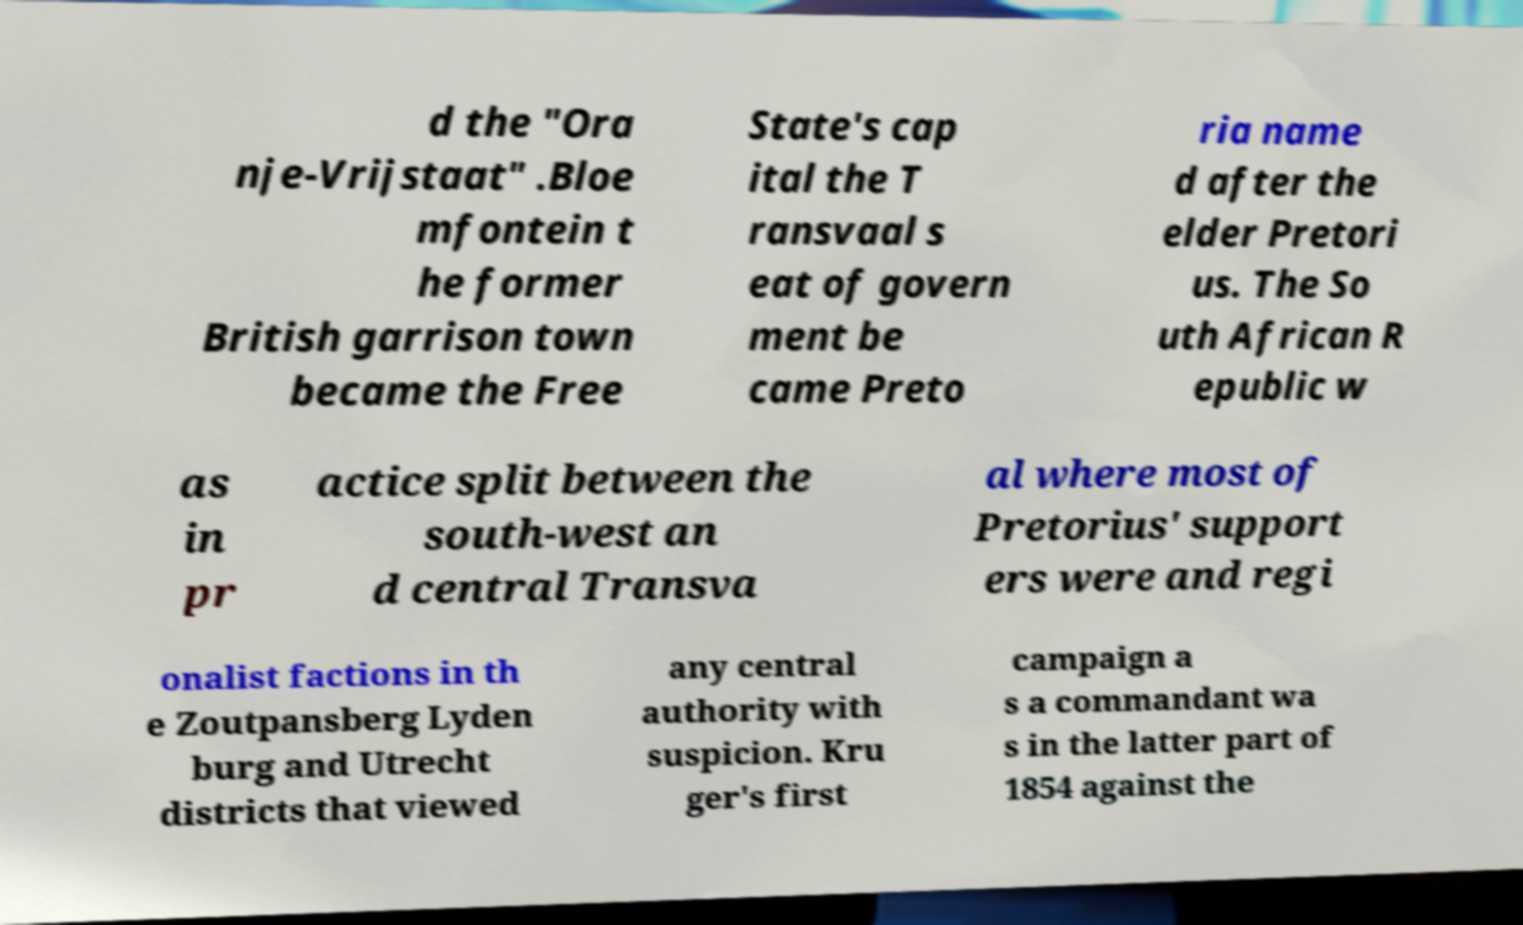What messages or text are displayed in this image? I need them in a readable, typed format. d the "Ora nje-Vrijstaat" .Bloe mfontein t he former British garrison town became the Free State's cap ital the T ransvaal s eat of govern ment be came Preto ria name d after the elder Pretori us. The So uth African R epublic w as in pr actice split between the south-west an d central Transva al where most of Pretorius' support ers were and regi onalist factions in th e Zoutpansberg Lyden burg and Utrecht districts that viewed any central authority with suspicion. Kru ger's first campaign a s a commandant wa s in the latter part of 1854 against the 